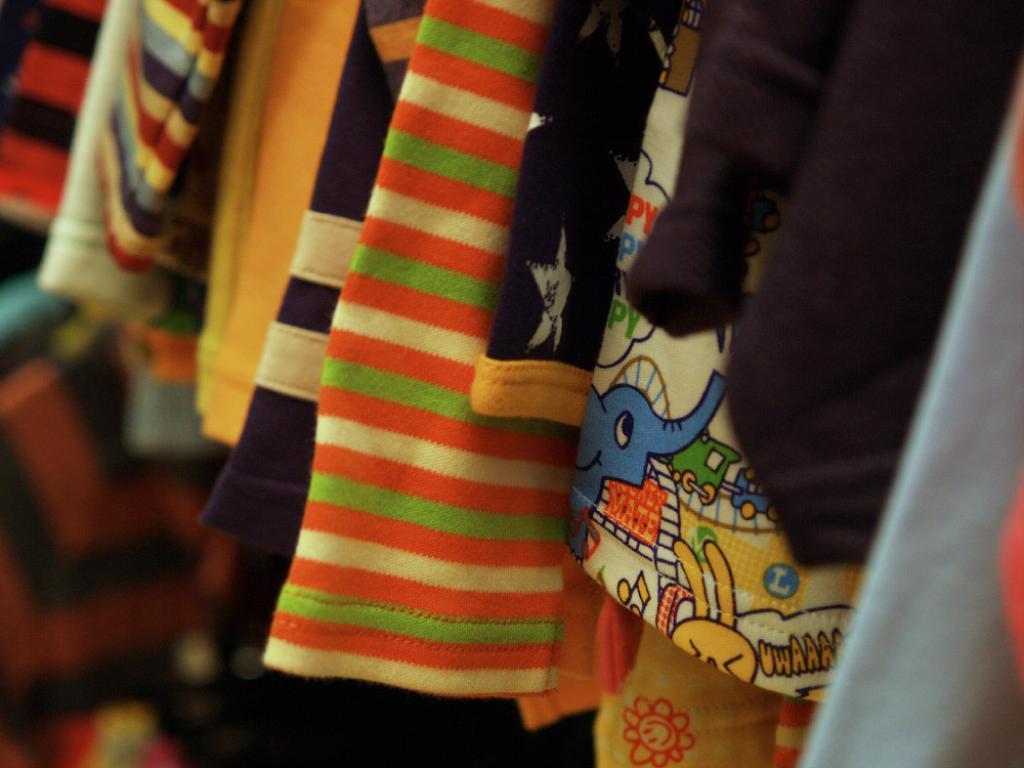What type of items can be seen in the image? There are clothes in the image. Can you describe the clothes in the image? The clothes are in different colors. Is there any snow visible in the image? There is no snow present in the image; it only features clothes in different colors. 